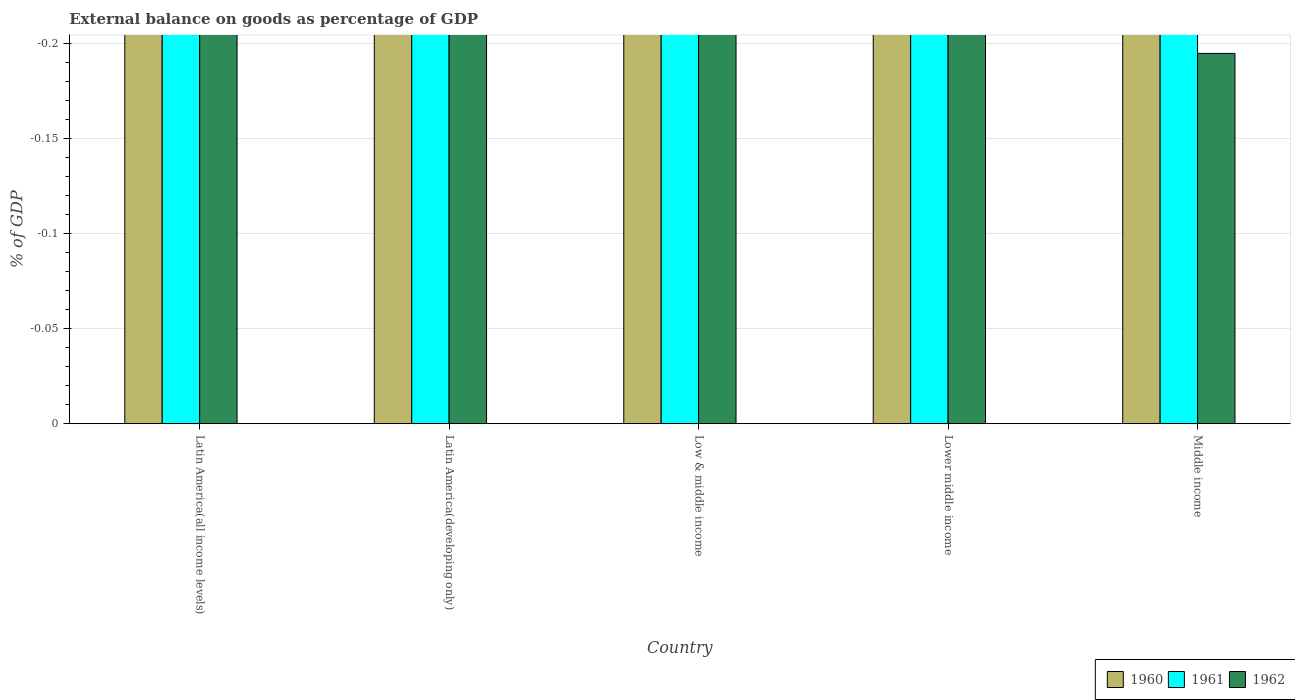Are the number of bars on each tick of the X-axis equal?
Ensure brevity in your answer.  Yes. How many bars are there on the 4th tick from the left?
Ensure brevity in your answer.  0. How many bars are there on the 1st tick from the right?
Provide a succinct answer. 0. What is the label of the 2nd group of bars from the left?
Offer a very short reply. Latin America(developing only). In how many cases, is the number of bars for a given country not equal to the number of legend labels?
Give a very brief answer. 5. What is the external balance on goods as percentage of GDP in 1961 in Low & middle income?
Your answer should be very brief. 0. Across all countries, what is the minimum external balance on goods as percentage of GDP in 1961?
Make the answer very short. 0. What is the difference between the external balance on goods as percentage of GDP in 1962 in Latin America(all income levels) and the external balance on goods as percentage of GDP in 1961 in Low & middle income?
Your response must be concise. 0. What is the average external balance on goods as percentage of GDP in 1961 per country?
Keep it short and to the point. 0. In how many countries, is the external balance on goods as percentage of GDP in 1962 greater than -0.19 %?
Your answer should be very brief. 0. In how many countries, is the external balance on goods as percentage of GDP in 1961 greater than the average external balance on goods as percentage of GDP in 1961 taken over all countries?
Ensure brevity in your answer.  0. Is it the case that in every country, the sum of the external balance on goods as percentage of GDP in 1960 and external balance on goods as percentage of GDP in 1962 is greater than the external balance on goods as percentage of GDP in 1961?
Provide a short and direct response. No. How many bars are there?
Ensure brevity in your answer.  0. What is the difference between two consecutive major ticks on the Y-axis?
Give a very brief answer. 0.05. Does the graph contain grids?
Offer a very short reply. Yes. Where does the legend appear in the graph?
Give a very brief answer. Bottom right. How are the legend labels stacked?
Your answer should be compact. Horizontal. What is the title of the graph?
Provide a short and direct response. External balance on goods as percentage of GDP. Does "1984" appear as one of the legend labels in the graph?
Ensure brevity in your answer.  No. What is the label or title of the Y-axis?
Provide a succinct answer. % of GDP. What is the % of GDP in 1961 in Latin America(all income levels)?
Give a very brief answer. 0. What is the % of GDP in 1962 in Latin America(all income levels)?
Ensure brevity in your answer.  0. What is the % of GDP in 1961 in Latin America(developing only)?
Ensure brevity in your answer.  0. What is the % of GDP in 1961 in Lower middle income?
Give a very brief answer. 0. What is the % of GDP in 1961 in Middle income?
Give a very brief answer. 0. What is the % of GDP of 1962 in Middle income?
Provide a succinct answer. 0. What is the total % of GDP of 1962 in the graph?
Your answer should be very brief. 0. What is the average % of GDP of 1960 per country?
Make the answer very short. 0. What is the average % of GDP of 1961 per country?
Provide a succinct answer. 0. What is the average % of GDP of 1962 per country?
Your answer should be very brief. 0. 